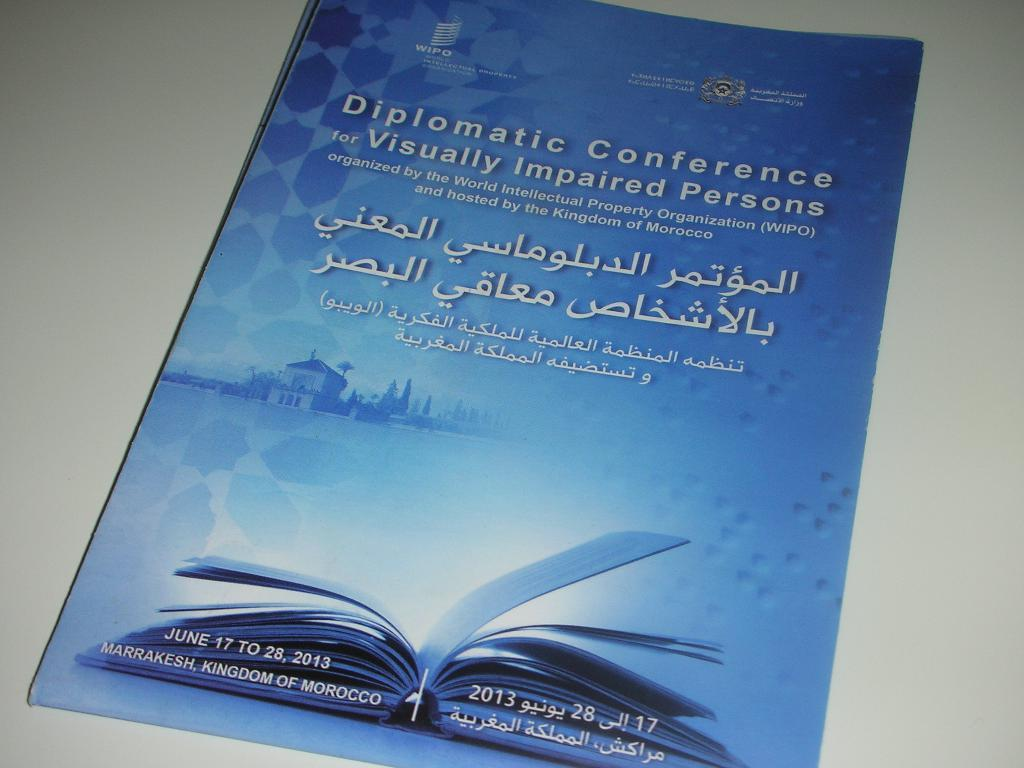<image>
Write a terse but informative summary of the picture. A leaflet which has the words Diplomatic Conference for Visually Impaired Persons on the cover. 